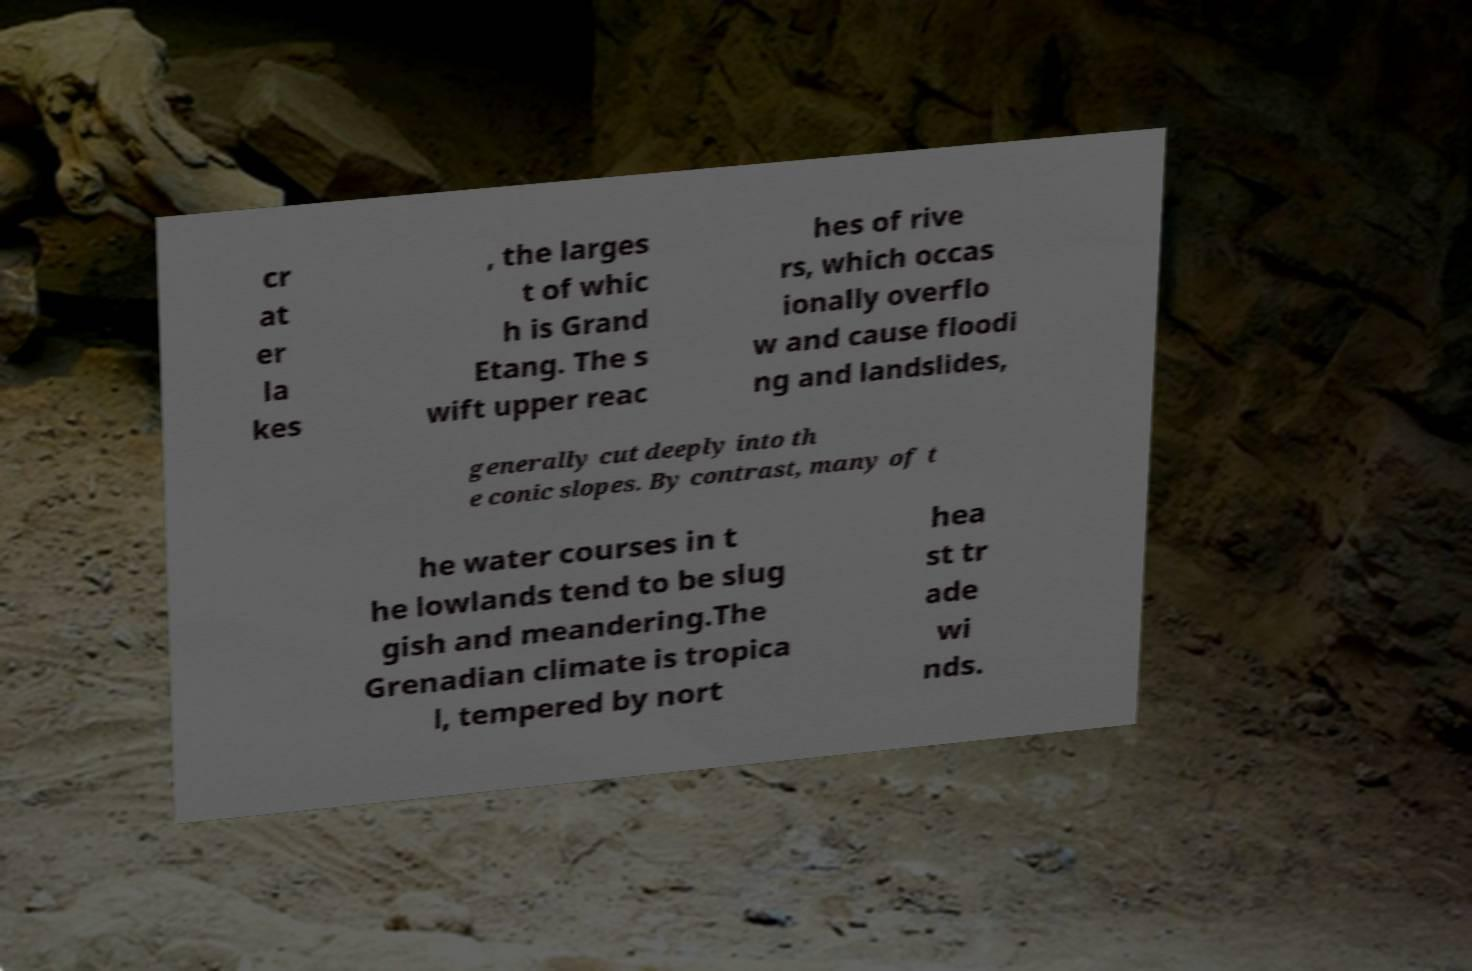For documentation purposes, I need the text within this image transcribed. Could you provide that? cr at er la kes , the larges t of whic h is Grand Etang. The s wift upper reac hes of rive rs, which occas ionally overflo w and cause floodi ng and landslides, generally cut deeply into th e conic slopes. By contrast, many of t he water courses in t he lowlands tend to be slug gish and meandering.The Grenadian climate is tropica l, tempered by nort hea st tr ade wi nds. 